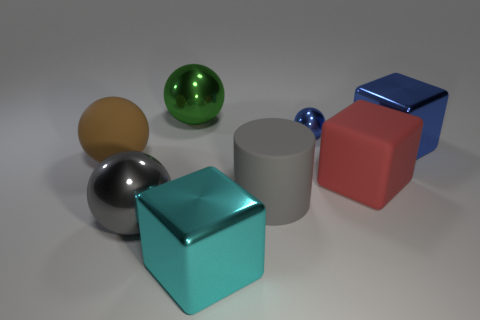Is there a big object that has the same color as the tiny metal thing? Yes, there is a big object that shares the same color as the small metallic sphere. The large cube located towards the front of the image has a similar shade of metallic cyan. 